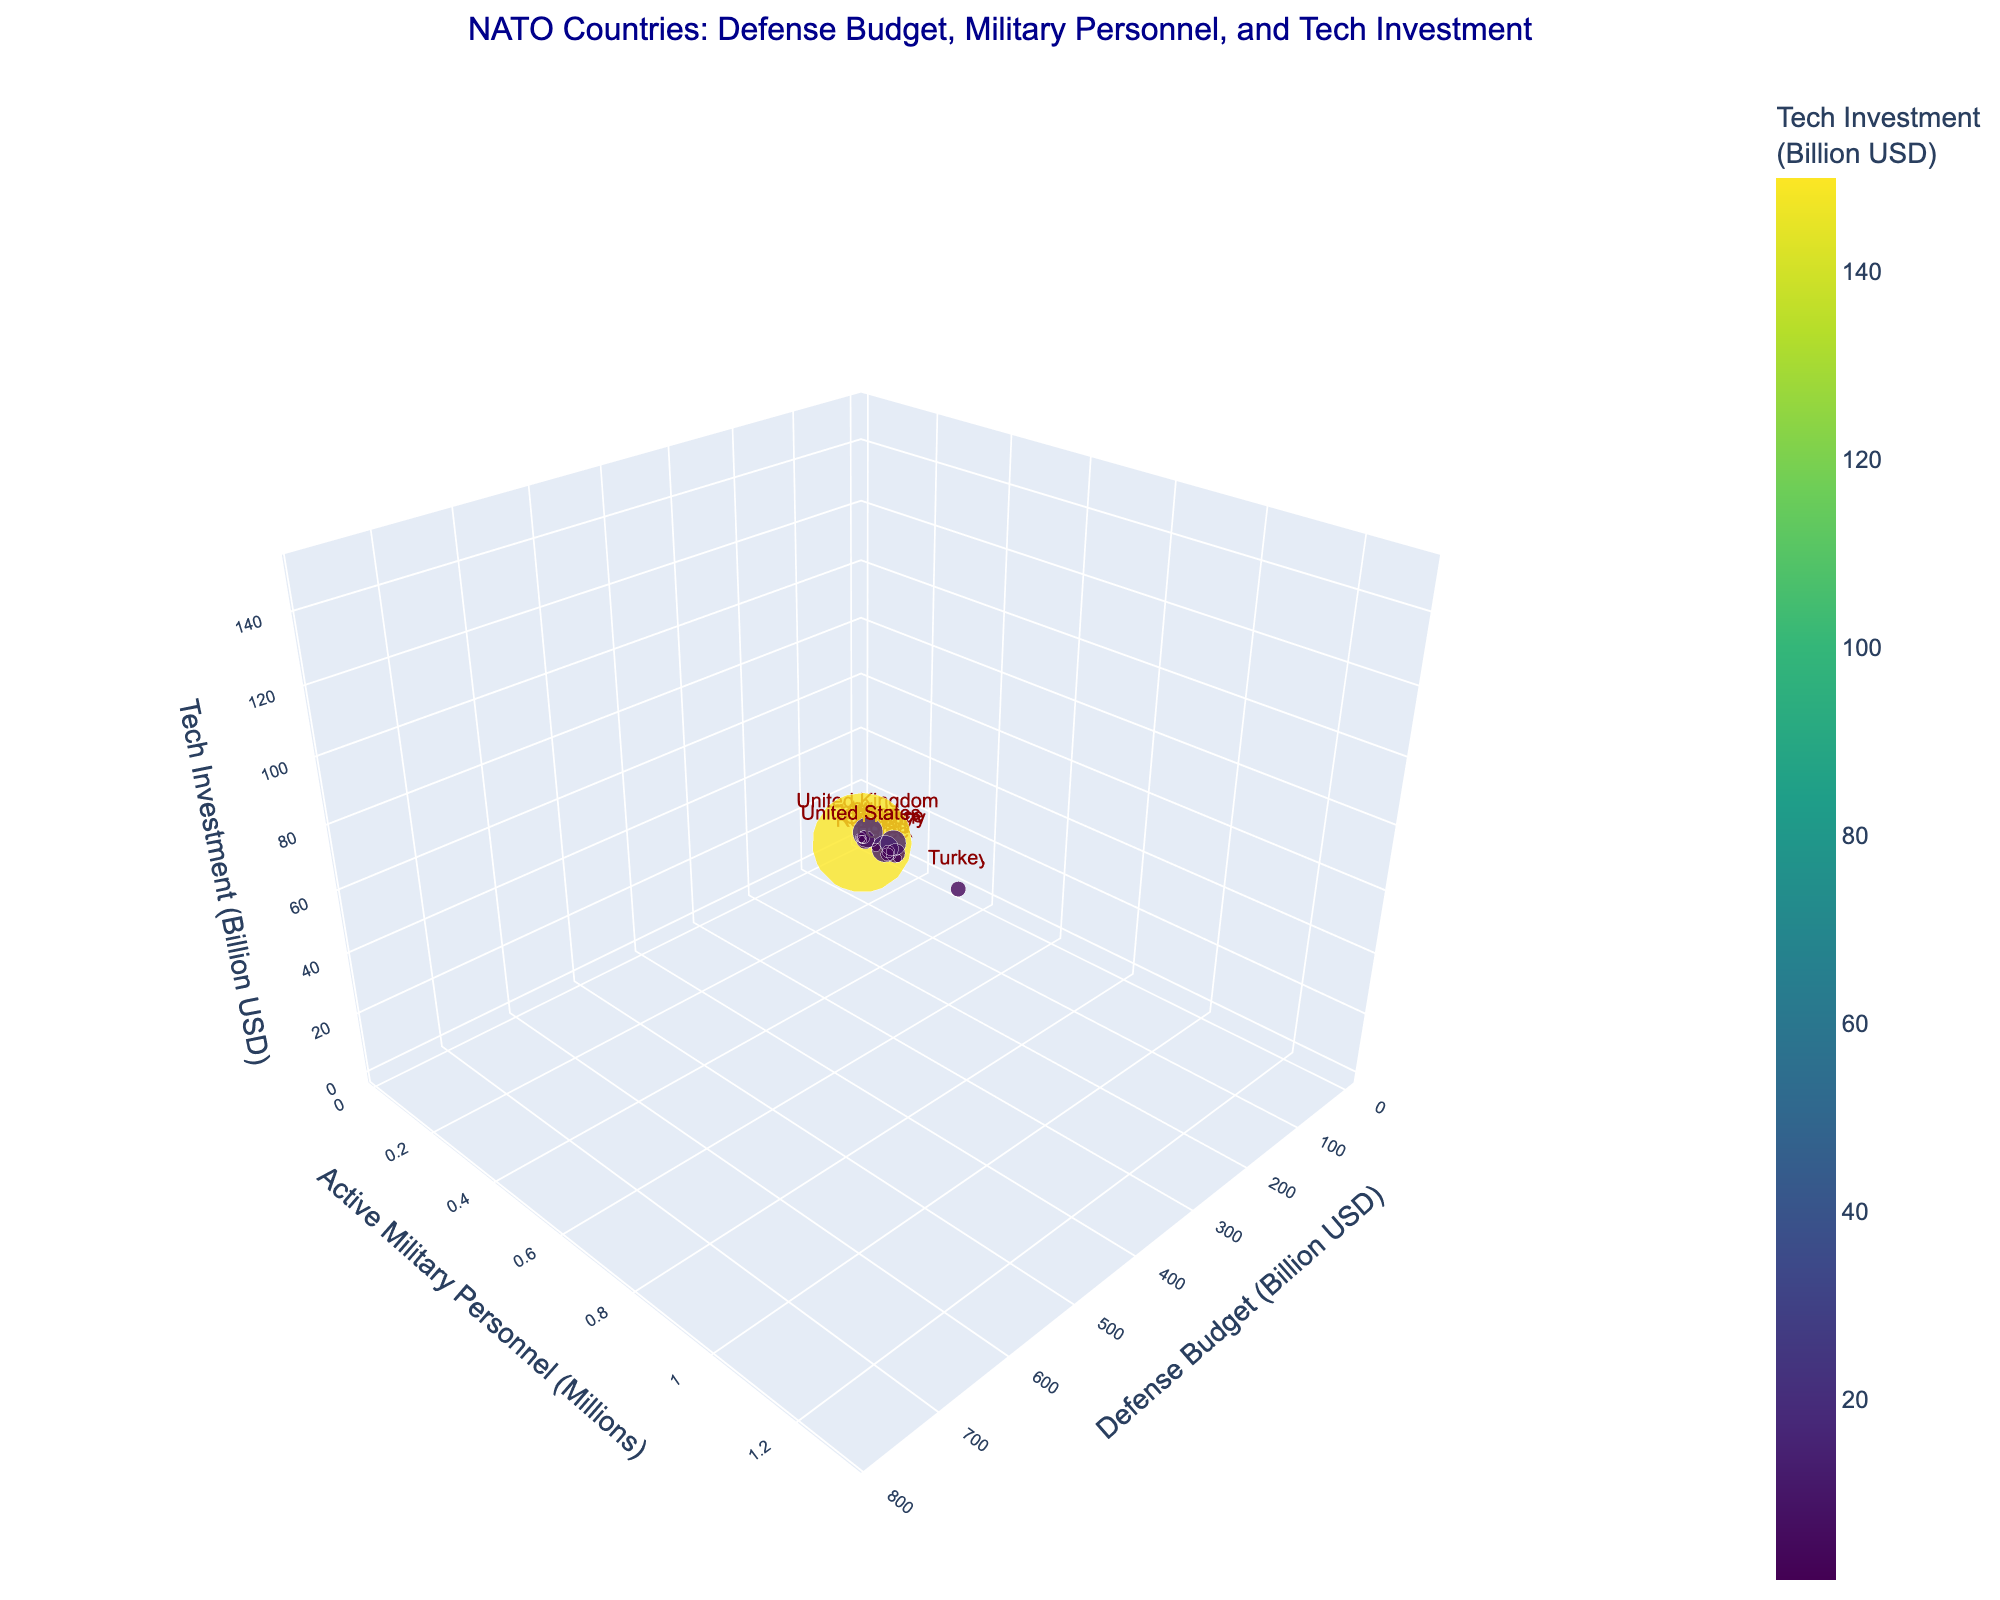How many NATO countries are represented in the figure? Count the number of unique data points in the figure, each representing a country.
Answer: 15 Which country has the highest defense budget based on the chart? Identify the largest bubble and its label, indicating the country with the highest defense spending.
Answer: United States What is the range of active military personnel (in millions) among NATO countries shown in the chart? Find the smallest and largest values along the y-axis (Active Military Personnel). The smallest is Belgium (0.025M), and the largest is Turkey (0.35M).
Answer: 0.025M to 0.35M How do the tech investments of Germany and France compare? Locate the positions of Germany and France on the z-axis (Tech Investment) and compare their values, which are both indicated by the height and color gradient of the bubbles.
Answer: Germany: 12B, France: 15B Which two countries have the closest tech investments in the figure? Analyze the positions along the z-axis (Tech Investment) and identify the closest values. Denmark and Greece are closest with 1.2B and 0.8B respectively.
Answer: Belgium (1.5B) and Romania (1B) Are there more countries with a defense budget above or below $50 billion? Count how many countries have bubbles positioned above and below the $50B mark on the x-axis (Defense Budget). Seven countries have more than $50B, and eight have less.
Answer: Below $50B Which country has the smallest defense budget, and what is its corresponding military personnel and tech investment? Identify the smallest bubble on the x-axis (Defense Budget), read its label, and find the corresponding y and z values. Denmark has the smallest defense budget at $5.1B, with 0.019M personnel and 1.2B tech investment.
Answer: Denmark, with 0.019M personnel and 1.2B tech investment What is the average tech investment of NATO countries with defense budgets above $50 billion? Identify countries with defense budgets above $50B, sum their tech investments, and divide by the number of countries. Those countries are the US, the UK, Germany, and France, with tech investments of $150B + $18B + $12B + $15B = $195B, and there are 4 such countries. The average is $195B / 4 = 48.75B
Answer: 48.75B Is there a correlation between defense budget and tech investment among NATO countries? Observe the scatter of bubbles along the x (Defense Budget) and z (Tech Investment) axes. Higher defense budgets generally trend with higher tech investments, especially for the US, suggesting a positive correlation.
Answer: Yes, positive correlation Which NATO country has a significantly higher active military personnel compared to its defense budget? Compare the size and y-axis (Active Military Personnel) position of bubbles to their x-axis (Defense Budget) positions. Turkey has a lower defense budget ($18.2B) but a relatively high number of active military personnel (0.35M).
Answer: Turkey 